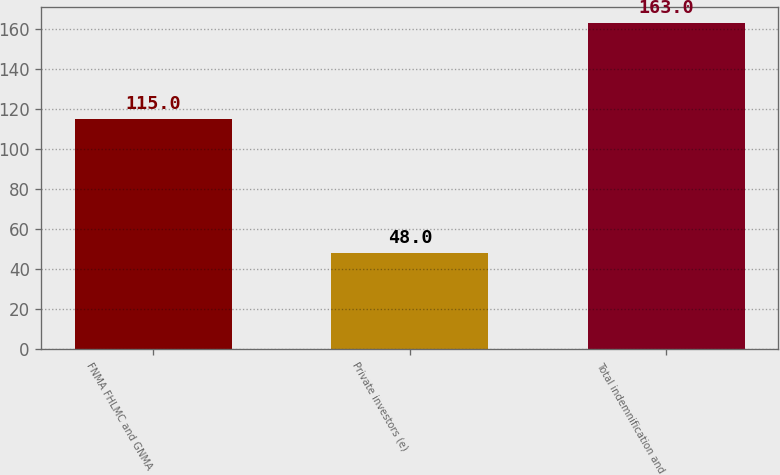Convert chart. <chart><loc_0><loc_0><loc_500><loc_500><bar_chart><fcel>FNMA FHLMC and GNMA<fcel>Private investors (e)<fcel>Total indemnification and<nl><fcel>115<fcel>48<fcel>163<nl></chart> 